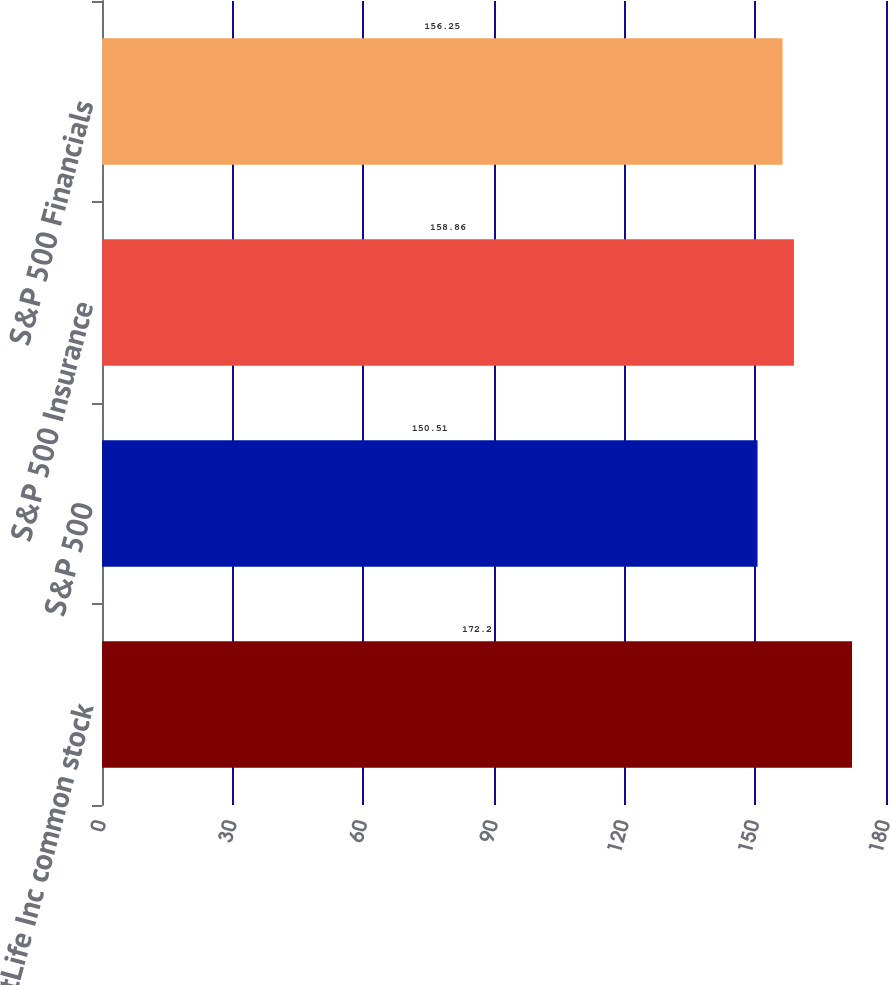Convert chart. <chart><loc_0><loc_0><loc_500><loc_500><bar_chart><fcel>MetLife Inc common stock<fcel>S&P 500<fcel>S&P 500 Insurance<fcel>S&P 500 Financials<nl><fcel>172.2<fcel>150.51<fcel>158.86<fcel>156.25<nl></chart> 